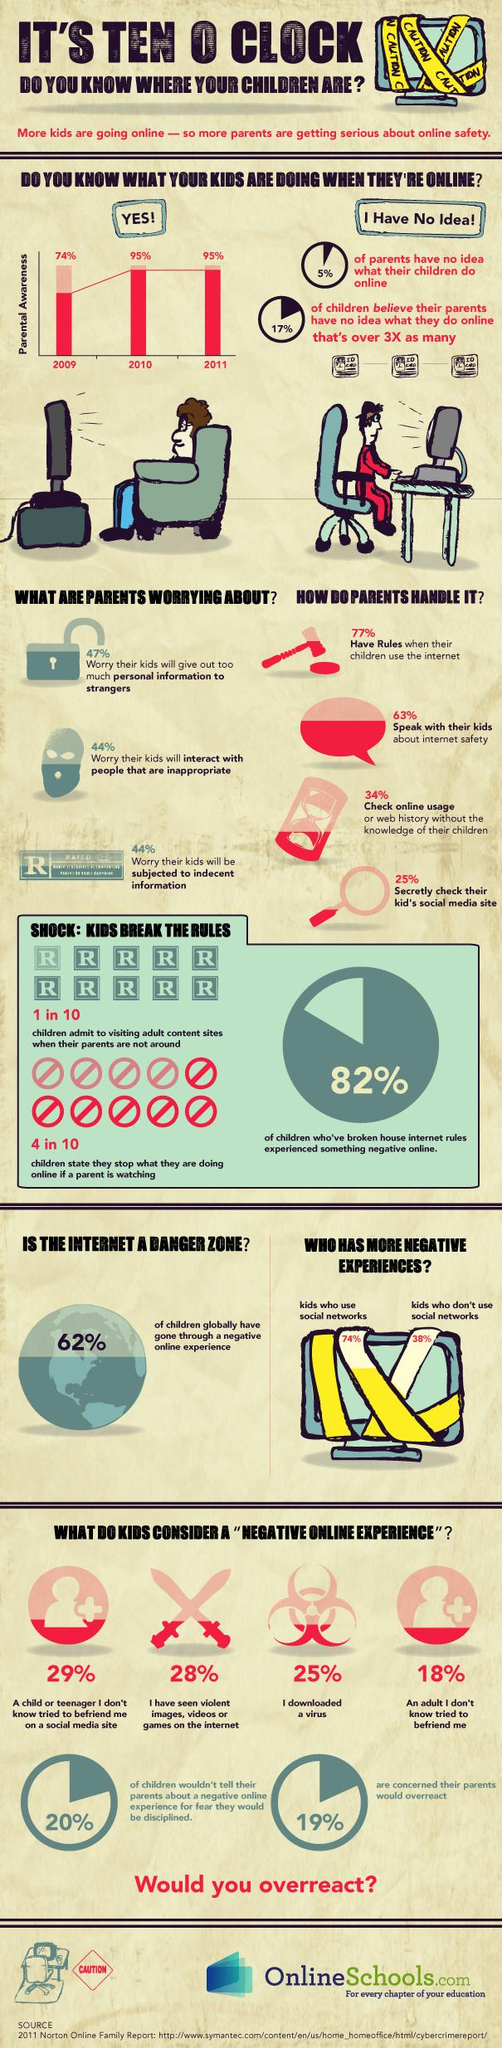Outline some significant characteristics in this image. According to the survey, a vast majority of 95% of parents have some understanding of their children's online activities. I would say that the children who have not used social media have more negative experiences compared to the children who use social media. According to the survey, 72% of children did not consider seeing violent images, videos, or games on the internet as a negative online experience. The level of parental awareness about children remains consistent across different years, including 2010 and 2011. A study conducted globally found that 38% of children have not experienced any negative online experiences. 